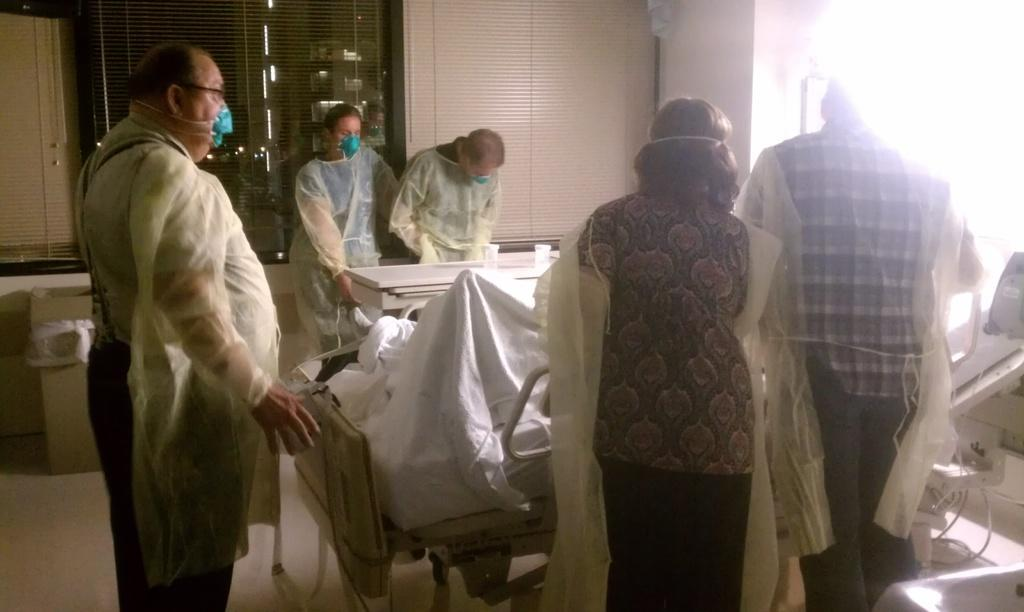What can be seen in the image? There are people standing in the image. What object is present in the image besides the people? There is a table in the image. What is on the table? There are glasses on the table. What type of test is being conducted in the image? There is no indication of a test being conducted in the image; it simply shows people standing near a table with glasses on it. 